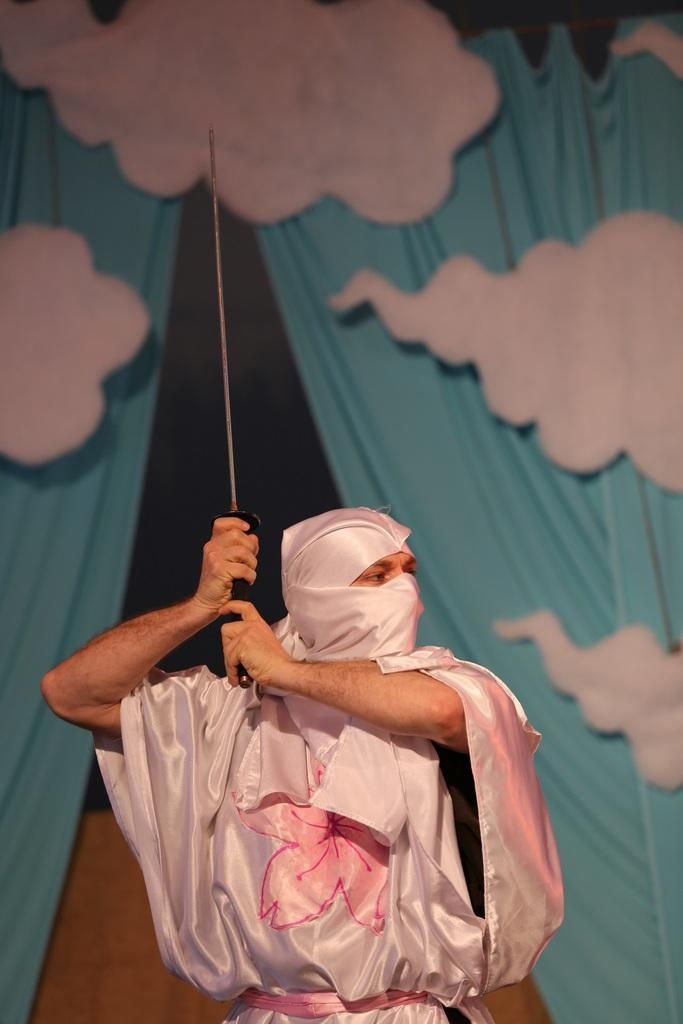What is the main subject of the image? There is a person standing in the middle of the image. What is the person holding in the image? The person is holding a sword. What can be seen behind the person in the image? There is a curtain behind the person. How many apples are on the furniture in the image? There are no apples or furniture present in the image. What type of oil can be seen dripping from the sword in the image? There is no oil present in the image, and the sword is not depicted as dripping anything. 